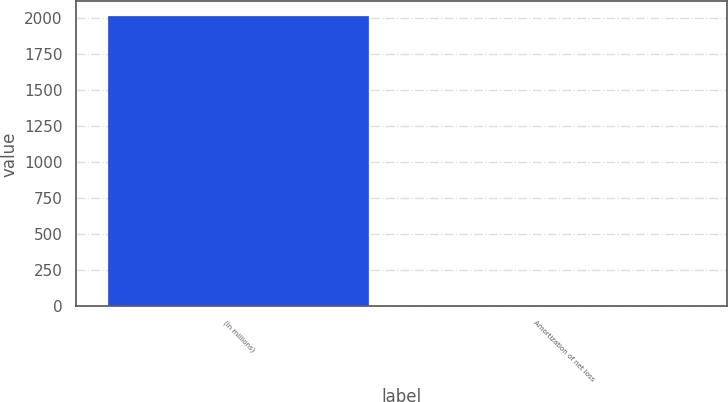Convert chart. <chart><loc_0><loc_0><loc_500><loc_500><bar_chart><fcel>(in millions)<fcel>Amortization of net loss<nl><fcel>2012<fcel>1<nl></chart> 